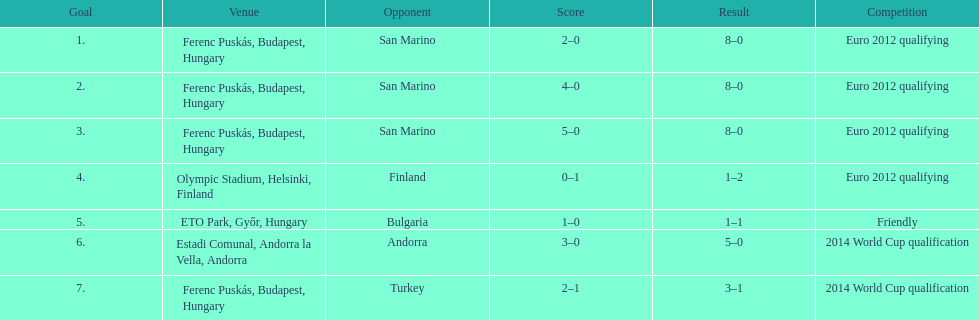How many games did he score but his team lost? 1. Write the full table. {'header': ['Goal', 'Venue', 'Opponent', 'Score', 'Result', 'Competition'], 'rows': [['1.', 'Ferenc Puskás, Budapest, Hungary', 'San Marino', '2–0', '8–0', 'Euro 2012 qualifying'], ['2.', 'Ferenc Puskás, Budapest, Hungary', 'San Marino', '4–0', '8–0', 'Euro 2012 qualifying'], ['3.', 'Ferenc Puskás, Budapest, Hungary', 'San Marino', '5–0', '8–0', 'Euro 2012 qualifying'], ['4.', 'Olympic Stadium, Helsinki, Finland', 'Finland', '0–1', '1–2', 'Euro 2012 qualifying'], ['5.', 'ETO Park, Győr, Hungary', 'Bulgaria', '1–0', '1–1', 'Friendly'], ['6.', 'Estadi Comunal, Andorra la Vella, Andorra', 'Andorra', '3–0', '5–0', '2014 World Cup qualification'], ['7.', 'Ferenc Puskás, Budapest, Hungary', 'Turkey', '2–1', '3–1', '2014 World Cup qualification']]} 